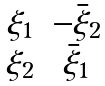<formula> <loc_0><loc_0><loc_500><loc_500>\begin{matrix} \xi _ { 1 } & - \bar { \xi } _ { 2 } \\ \xi _ { 2 } & \bar { \xi } _ { 1 } \\ \end{matrix}</formula> 